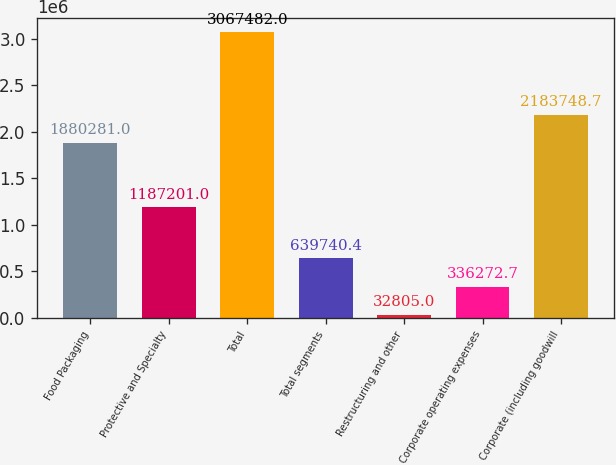Convert chart to OTSL. <chart><loc_0><loc_0><loc_500><loc_500><bar_chart><fcel>Food Packaging<fcel>Protective and Specialty<fcel>Total<fcel>Total segments<fcel>Restructuring and other<fcel>Corporate operating expenses<fcel>Corporate (including goodwill<nl><fcel>1.88028e+06<fcel>1.1872e+06<fcel>3.06748e+06<fcel>639740<fcel>32805<fcel>336273<fcel>2.18375e+06<nl></chart> 